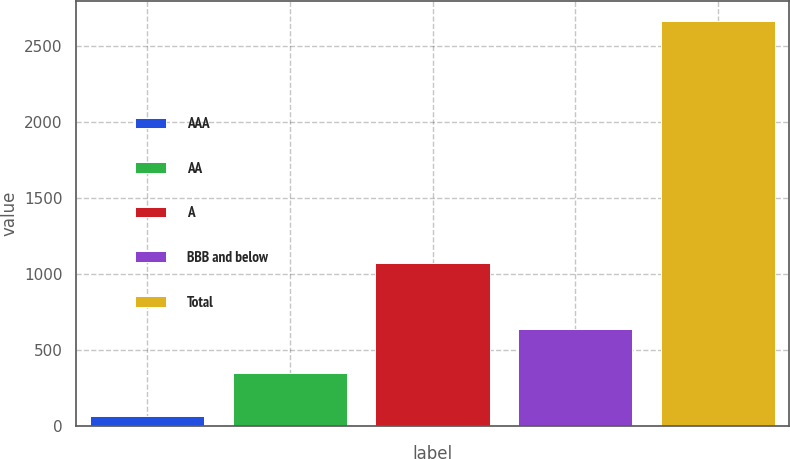Convert chart to OTSL. <chart><loc_0><loc_0><loc_500><loc_500><bar_chart><fcel>AAA<fcel>AA<fcel>A<fcel>BBB and below<fcel>Total<nl><fcel>66<fcel>346<fcel>1074<fcel>640<fcel>2662<nl></chart> 